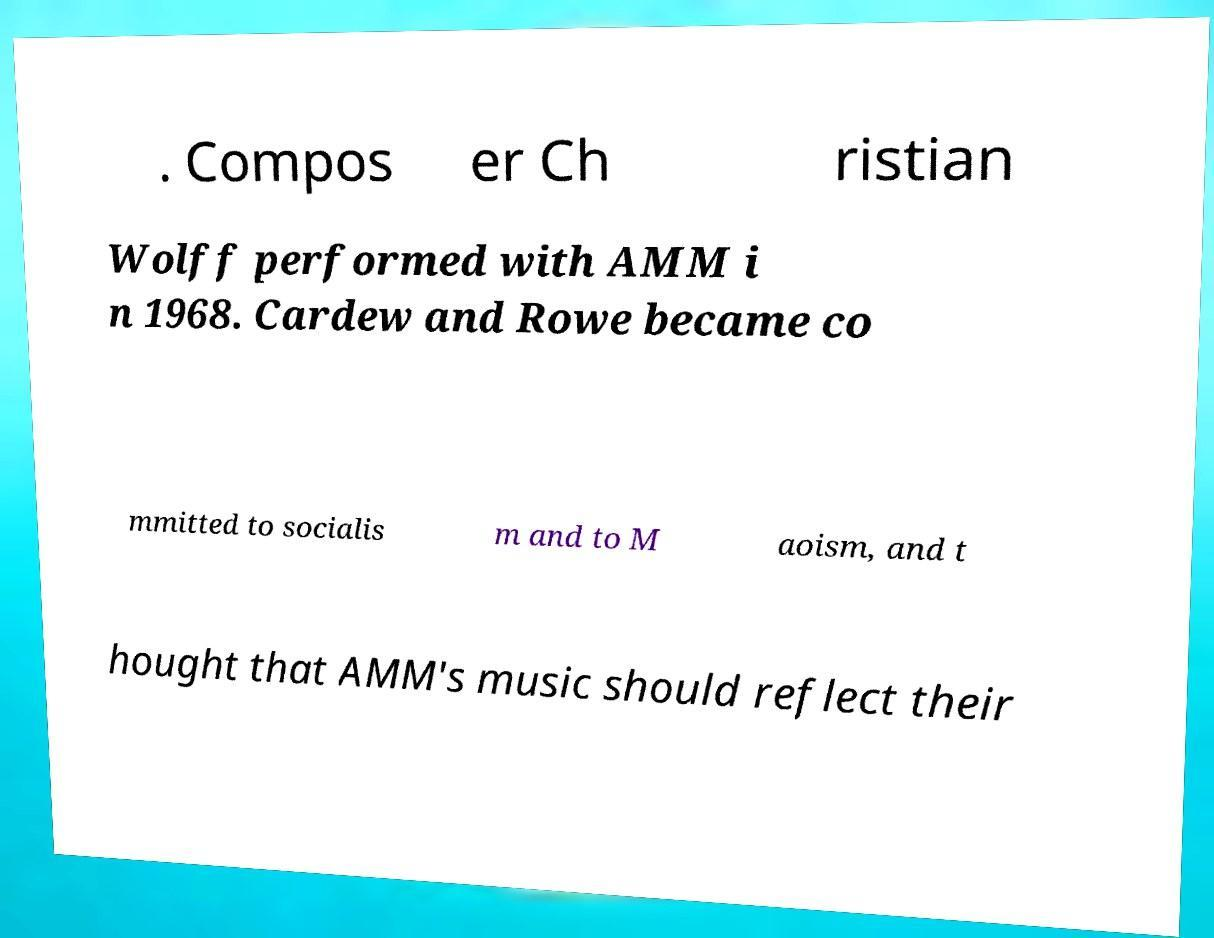Please read and relay the text visible in this image. What does it say? . Compos er Ch ristian Wolff performed with AMM i n 1968. Cardew and Rowe became co mmitted to socialis m and to M aoism, and t hought that AMM's music should reflect their 